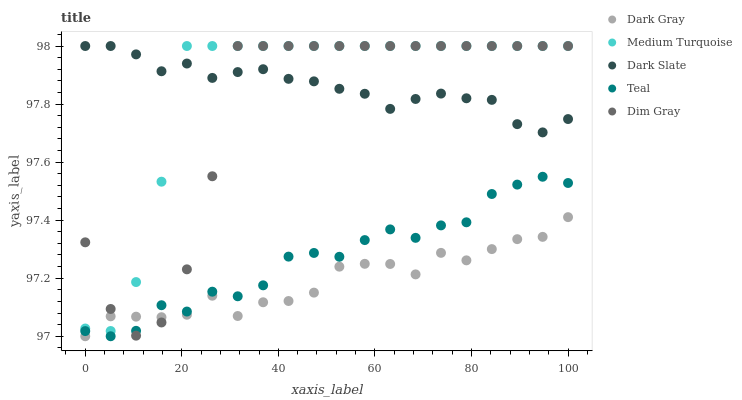Does Dark Gray have the minimum area under the curve?
Answer yes or no. Yes. Does Dark Slate have the maximum area under the curve?
Answer yes or no. Yes. Does Dim Gray have the minimum area under the curve?
Answer yes or no. No. Does Dim Gray have the maximum area under the curve?
Answer yes or no. No. Is Dark Slate the smoothest?
Answer yes or no. Yes. Is Dim Gray the roughest?
Answer yes or no. Yes. Is Dim Gray the smoothest?
Answer yes or no. No. Is Dark Slate the roughest?
Answer yes or no. No. Does Dark Gray have the lowest value?
Answer yes or no. Yes. Does Dim Gray have the lowest value?
Answer yes or no. No. Does Medium Turquoise have the highest value?
Answer yes or no. Yes. Does Teal have the highest value?
Answer yes or no. No. Is Teal less than Medium Turquoise?
Answer yes or no. Yes. Is Dark Slate greater than Dark Gray?
Answer yes or no. Yes. Does Medium Turquoise intersect Dark Gray?
Answer yes or no. Yes. Is Medium Turquoise less than Dark Gray?
Answer yes or no. No. Is Medium Turquoise greater than Dark Gray?
Answer yes or no. No. Does Teal intersect Medium Turquoise?
Answer yes or no. No. 